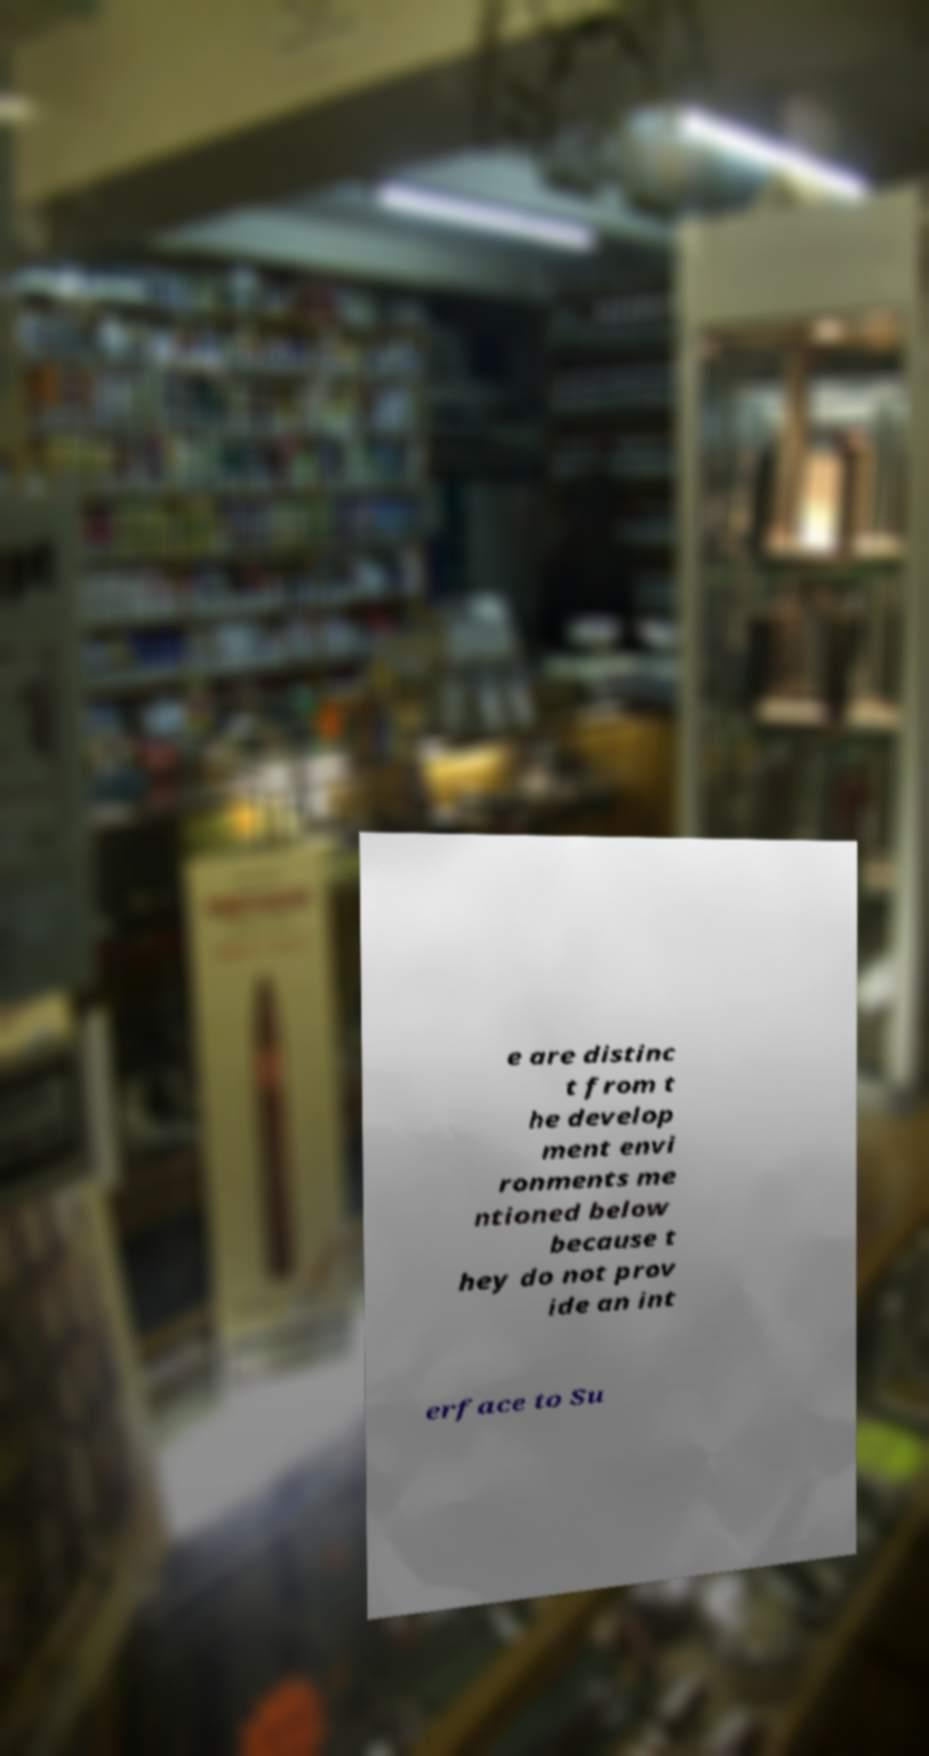Please identify and transcribe the text found in this image. e are distinc t from t he develop ment envi ronments me ntioned below because t hey do not prov ide an int erface to Su 